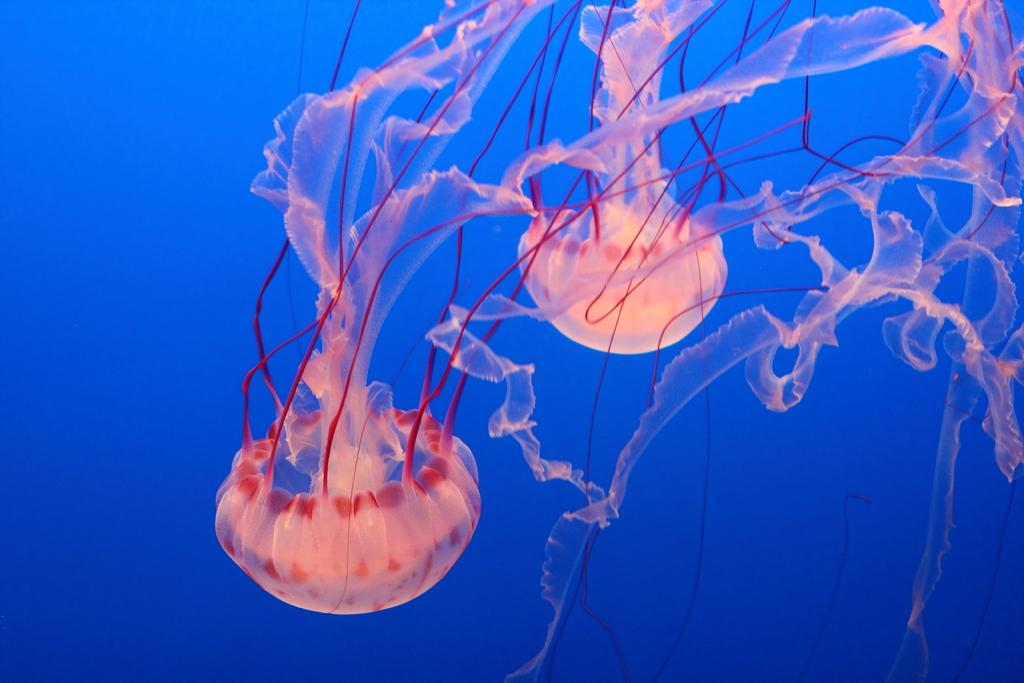What type of sea creatures are present in the image? There are jellyfishes in the image. Where are the jellyfishes located? The jellyfishes are inside the water. What type of apparatus is being used to create the mist in the image? There is no mist present in the image, and no apparatus is being used. 